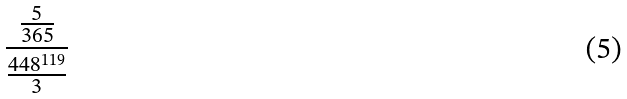<formula> <loc_0><loc_0><loc_500><loc_500>\frac { \frac { 5 } { 3 6 5 } } { \frac { 4 4 8 ^ { 1 1 9 } } { 3 } }</formula> 